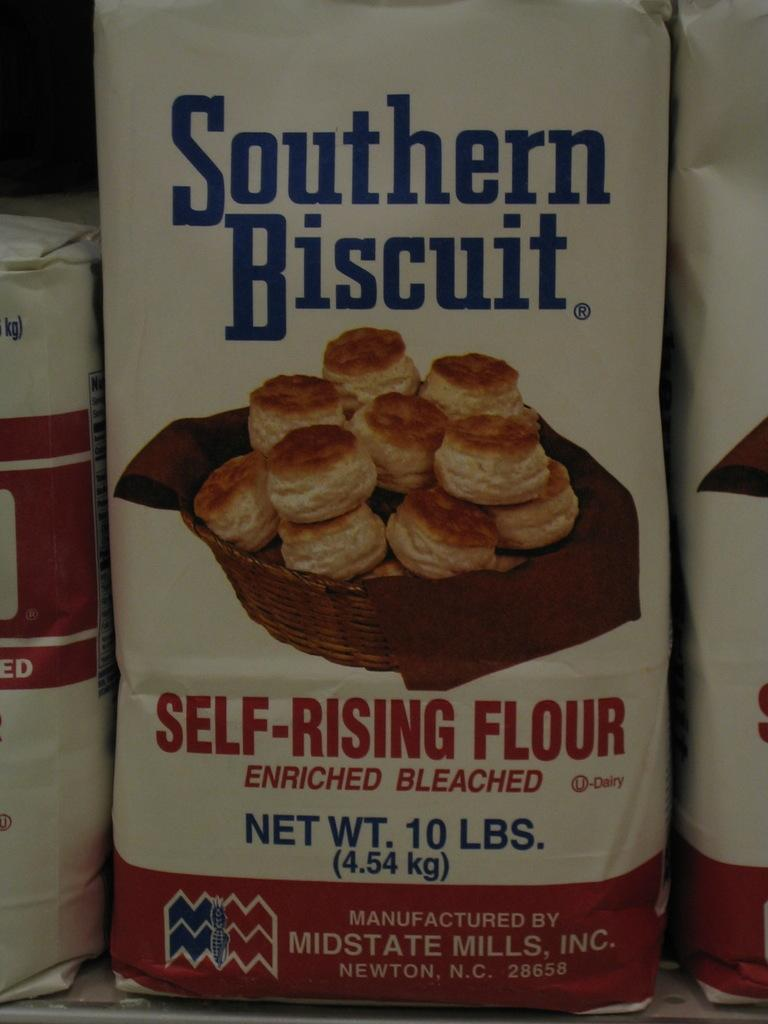What is located in the middle of the image? There is a packet in the middle of the image. What is featured on the packet? There is a poster on the packet, which includes food items, text, a logo, and a basket. Are there any other packets visible in the image? Yes, there are packets on the left and right sides of the image. What type of weather can be seen in the image? There is no weather depicted in the image; it focuses on the packet and its poster. Can you describe the playground visible in the image? There is no playground present in the image; it features a packet with a poster on it. 